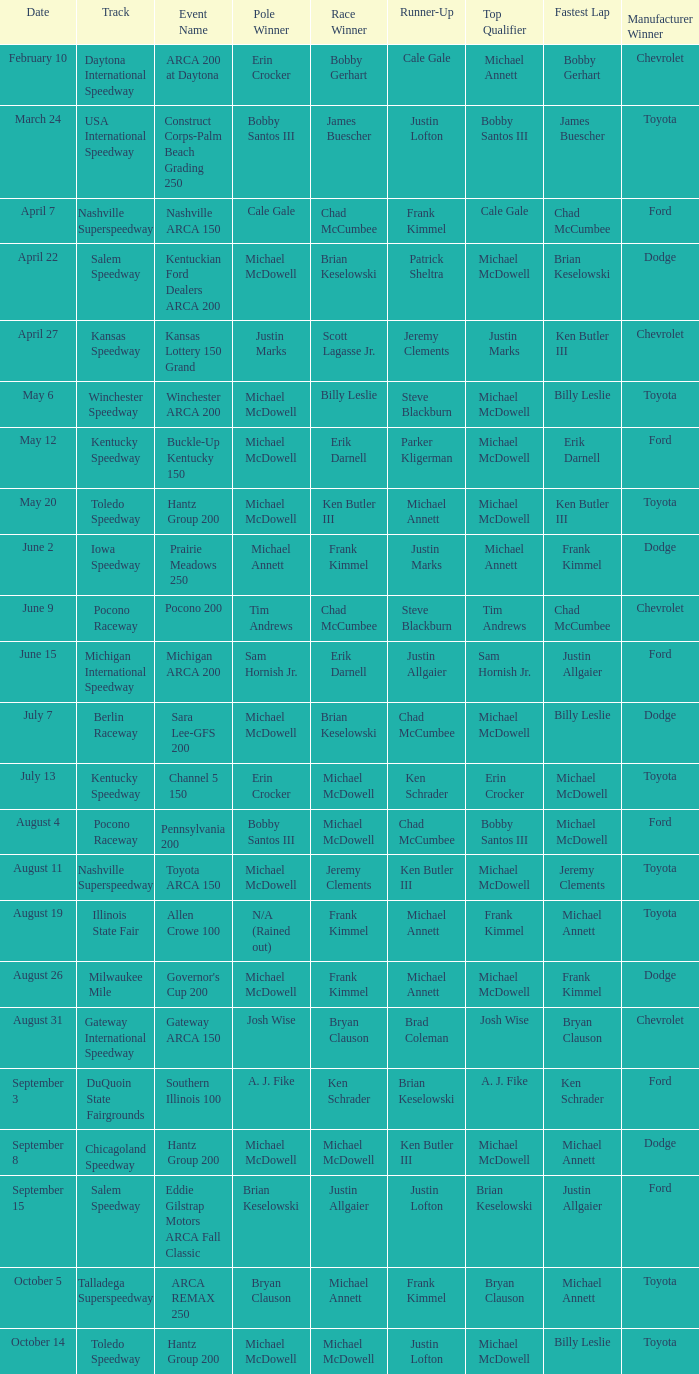Tell me the pole winner of may 12 Michael McDowell. 